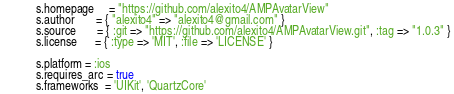<code> <loc_0><loc_0><loc_500><loc_500><_Ruby_>  s.homepage     = "https://github.com/alexito4/AMPAvatarView"
  s.author       = { "alexito4" => "alexito4@gmail.com" }
  s.source       = { :git => "https://github.com/alexito4/AMPAvatarView.git", :tag => "1.0.3" }
  s.license      = { :type => 'MIT', :file => 'LICENSE' }

  s.platform = :ios
  s.requires_arc = true
  s.frameworks  = 'UIKit', 'QuartzCore'</code> 